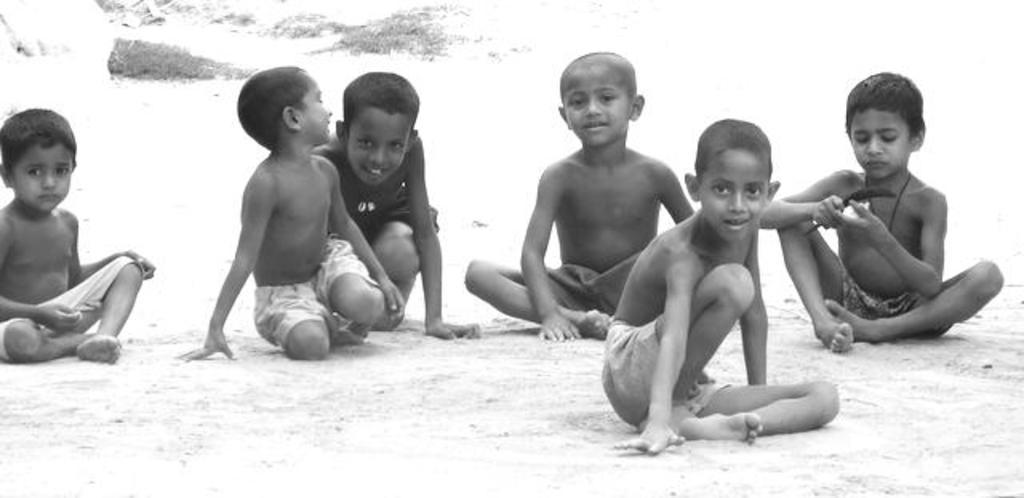Please provide a concise description of this image. In this image there are group of boys sitting, there is a boy holding an object, in this image there is an object that looks like the plants, the background of the image is white in color. 